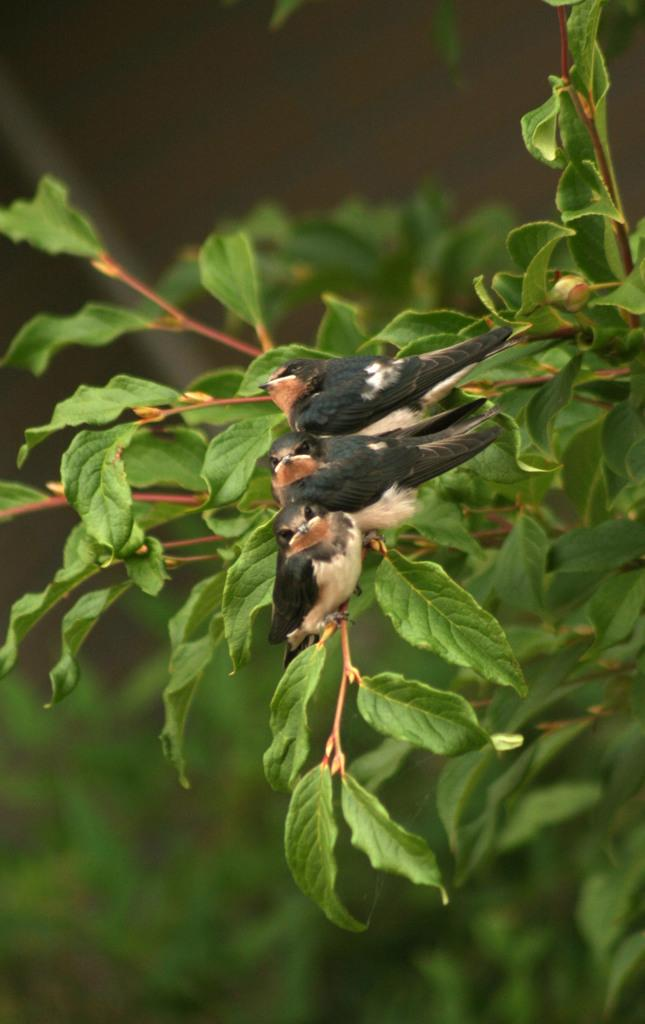What type of animals can be seen in the image? There are birds in the image. Where are the birds located in the image? The birds are sitting on the stem of a tree. Can you describe the background of the image? The backdrop of the image is blurred. What type of silk material is draped over the tiger in the image? There is no tiger or silk material present in the image. 